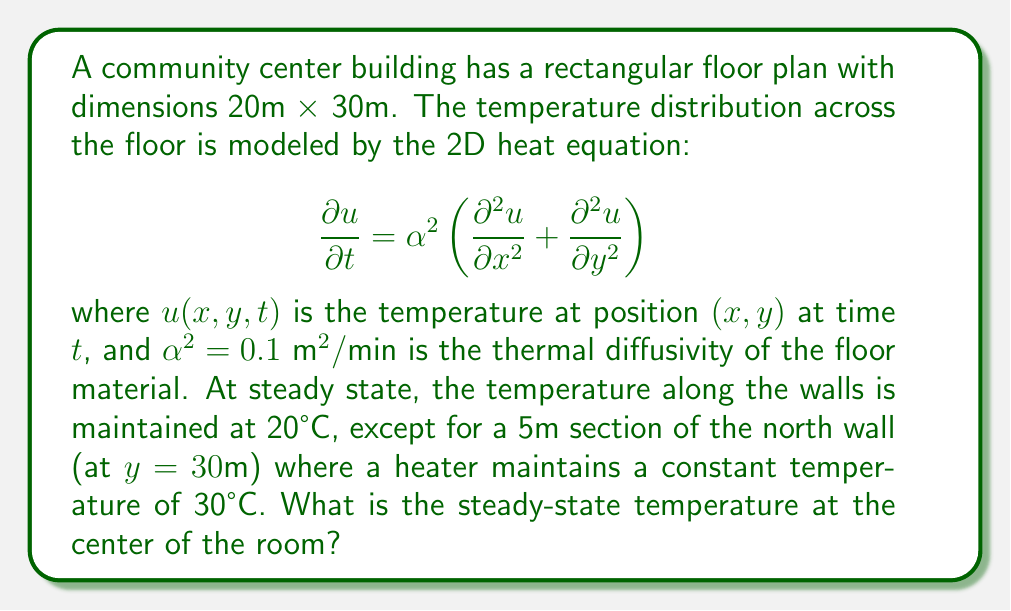Give your solution to this math problem. To solve this problem, we need to follow these steps:

1) At steady state, the time derivative becomes zero, so our equation reduces to:

   $$\frac{\partial^2 u}{\partial x^2} + \frac{\partial^2 u}{\partial y^2} = 0$$

   This is Laplace's equation.

2) The boundary conditions are:
   - $u(x,0) = u(x,30) = 20$ for $0 \leq x \leq 20$, except for $7.5 \leq x \leq 12.5$ on the north wall
   - $u(0,y) = u(20,y) = 20$ for $0 \leq y \leq 30$
   - $u(x,30) = 30$ for $7.5 \leq x \leq 12.5$

3) This problem can be solved using separation of variables and Fourier series. The solution will have the form:

   $$u(x,y) = 20 + \sum_{n=1}^{\infty} A_n \sin(\frac{n\pi x}{20}) \sinh(\frac{n\pi y}{20})$$

4) The coefficients $A_n$ are determined by the boundary condition at $y=30$:

   $$10 = \sum_{n=1}^{\infty} A_n \sin(\frac{n\pi x}{20}) \sinh(\frac{3n\pi}{2})$$ for $7.5 \leq x \leq 12.5$

5) Using Fourier series techniques, we can determine:

   $$A_n = \frac{40}{n\pi \sinh(\frac{3n\pi}{2})} \sin(\frac{n\pi}{4}) \sin(\frac{n\pi}{8})$$

6) The temperature at the center of the room $(10,15)$ is:

   $$u(10,15) = 20 + \sum_{n=1}^{\infty} A_n \sin(\frac{n\pi}{2}) \sinh(\frac{3n\pi}{4})$$

7) Calculating the first few terms of this series (the series converges quickly):

   $$u(10,15) \approx 22.16°C$$
Answer: 22.16°C 